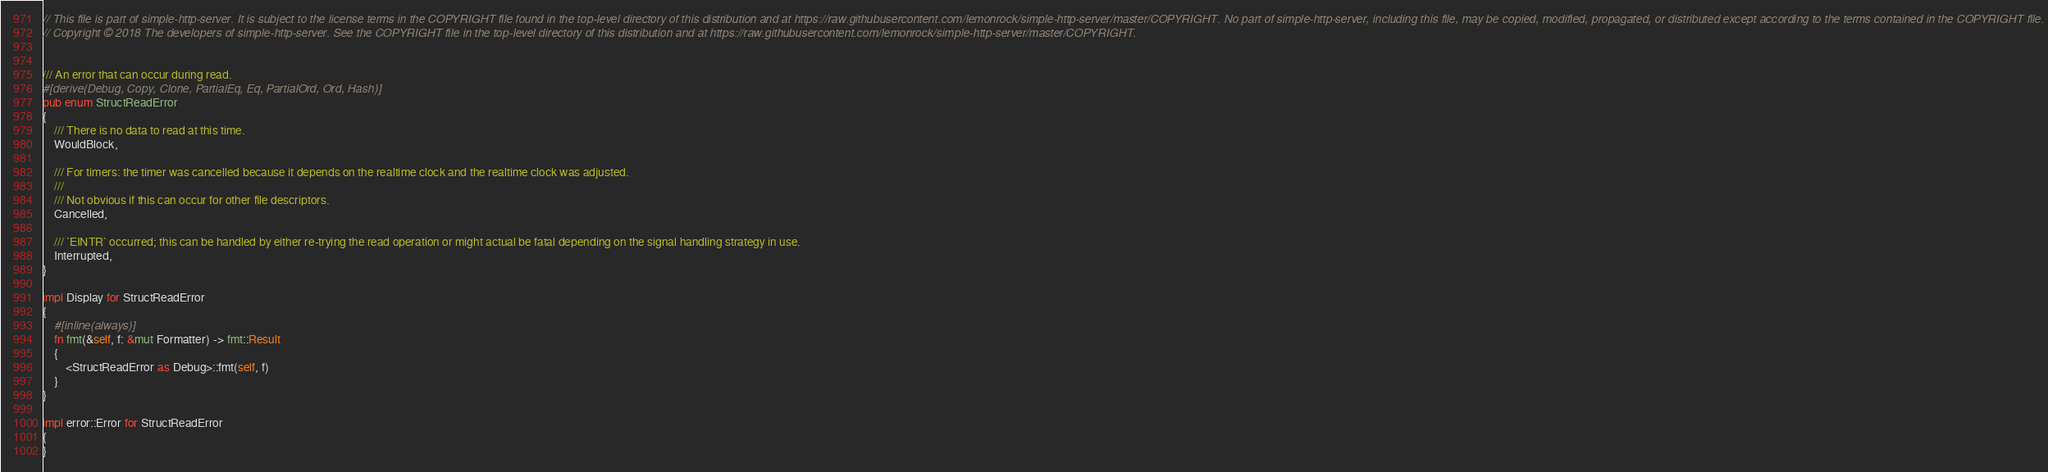<code> <loc_0><loc_0><loc_500><loc_500><_Rust_>// This file is part of simple-http-server. It is subject to the license terms in the COPYRIGHT file found in the top-level directory of this distribution and at https://raw.githubusercontent.com/lemonrock/simple-http-server/master/COPYRIGHT. No part of simple-http-server, including this file, may be copied, modified, propagated, or distributed except according to the terms contained in the COPYRIGHT file.
// Copyright © 2018 The developers of simple-http-server. See the COPYRIGHT file in the top-level directory of this distribution and at https://raw.githubusercontent.com/lemonrock/simple-http-server/master/COPYRIGHT.


/// An error that can occur during read.
#[derive(Debug, Copy, Clone, PartialEq, Eq, PartialOrd, Ord, Hash)]
pub enum StructReadError
{
	/// There is no data to read at this time.
	WouldBlock,

	/// For timers: the timer was cancelled because it depends on the realtime clock and the realtime clock was adjusted.
	///
	/// Not obvious if this can occur for other file descriptors.
	Cancelled,

	/// `EINTR` occurred; this can be handled by either re-trying the read operation or might actual be fatal depending on the signal handling strategy in use.
	Interrupted,
}

impl Display for StructReadError
{
	#[inline(always)]
	fn fmt(&self, f: &mut Formatter) -> fmt::Result
	{
		<StructReadError as Debug>::fmt(self, f)
	}
}

impl error::Error for StructReadError
{
}
</code> 